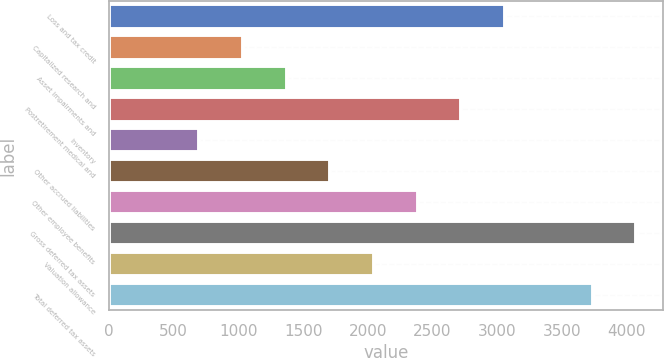Convert chart to OTSL. <chart><loc_0><loc_0><loc_500><loc_500><bar_chart><fcel>Loss and tax credit<fcel>Capitalized research and<fcel>Asset impairments and<fcel>Postretirement medical and<fcel>Inventory<fcel>Other accrued liabilities<fcel>Other employee benefits<fcel>Gross deferred tax assets<fcel>Valuation allowance<fcel>Total deferred tax assets<nl><fcel>3062.2<fcel>1035.4<fcel>1373.2<fcel>2724.4<fcel>697.6<fcel>1711<fcel>2386.6<fcel>4075.6<fcel>2048.8<fcel>3737.8<nl></chart> 